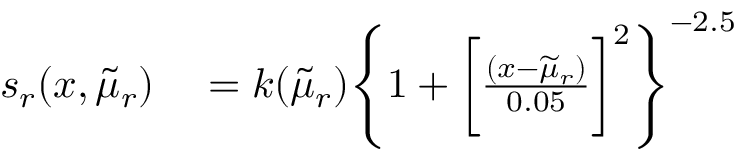Convert formula to latex. <formula><loc_0><loc_0><loc_500><loc_500>\begin{array} { r l } { s _ { r } ( x , \widetilde { \mu } _ { r } ) } & = k ( \widetilde { \mu } _ { r } ) \left \{ 1 + \left [ \frac { ( x - \widetilde { \mu } _ { r } ) } { 0 . 0 5 } \right ] ^ { 2 } \right \} ^ { - 2 . 5 } } \end{array}</formula> 